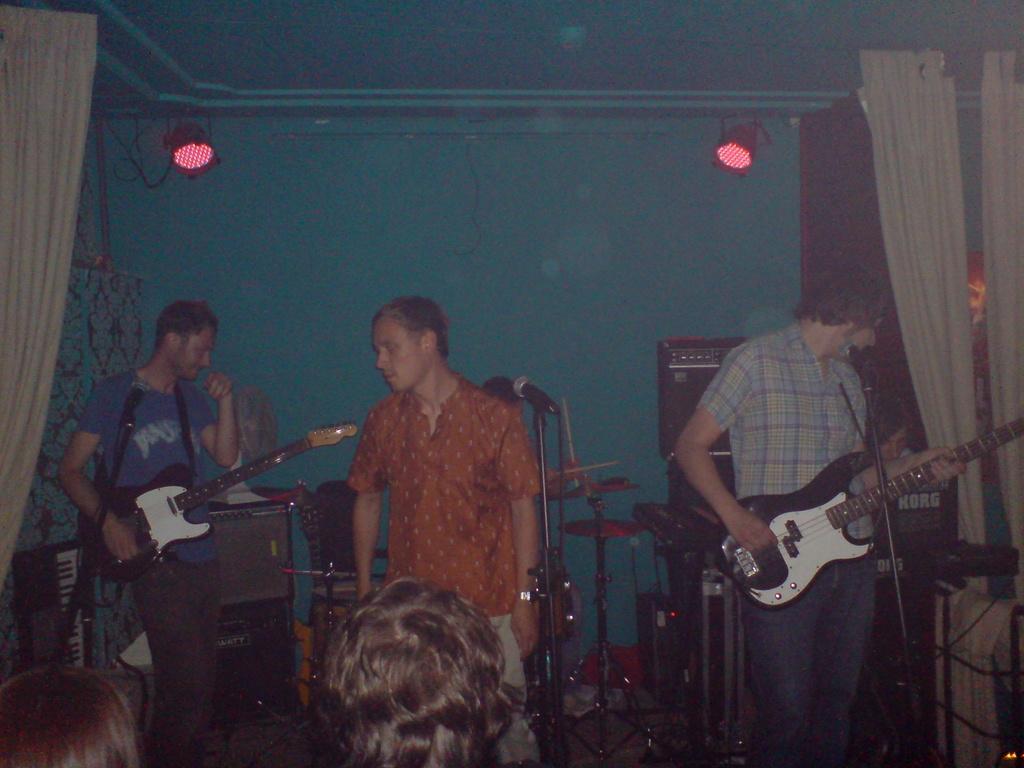In one or two sentences, can you explain what this image depicts? This is a picture taken in a room, there are three people standing on the floor. The two people are playing the guitar and the man in orange shirt singing a song in front of the man there is a microphone with stand. Background of this people there is a wall which is in blue color and a lights. 